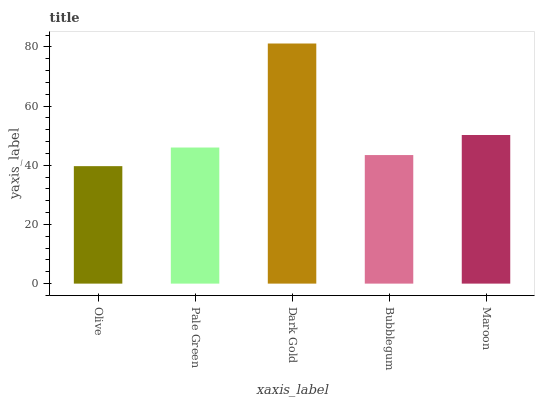Is Pale Green the minimum?
Answer yes or no. No. Is Pale Green the maximum?
Answer yes or no. No. Is Pale Green greater than Olive?
Answer yes or no. Yes. Is Olive less than Pale Green?
Answer yes or no. Yes. Is Olive greater than Pale Green?
Answer yes or no. No. Is Pale Green less than Olive?
Answer yes or no. No. Is Pale Green the high median?
Answer yes or no. Yes. Is Pale Green the low median?
Answer yes or no. Yes. Is Dark Gold the high median?
Answer yes or no. No. Is Maroon the low median?
Answer yes or no. No. 